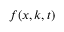<formula> <loc_0><loc_0><loc_500><loc_500>f ( x , k , t )</formula> 